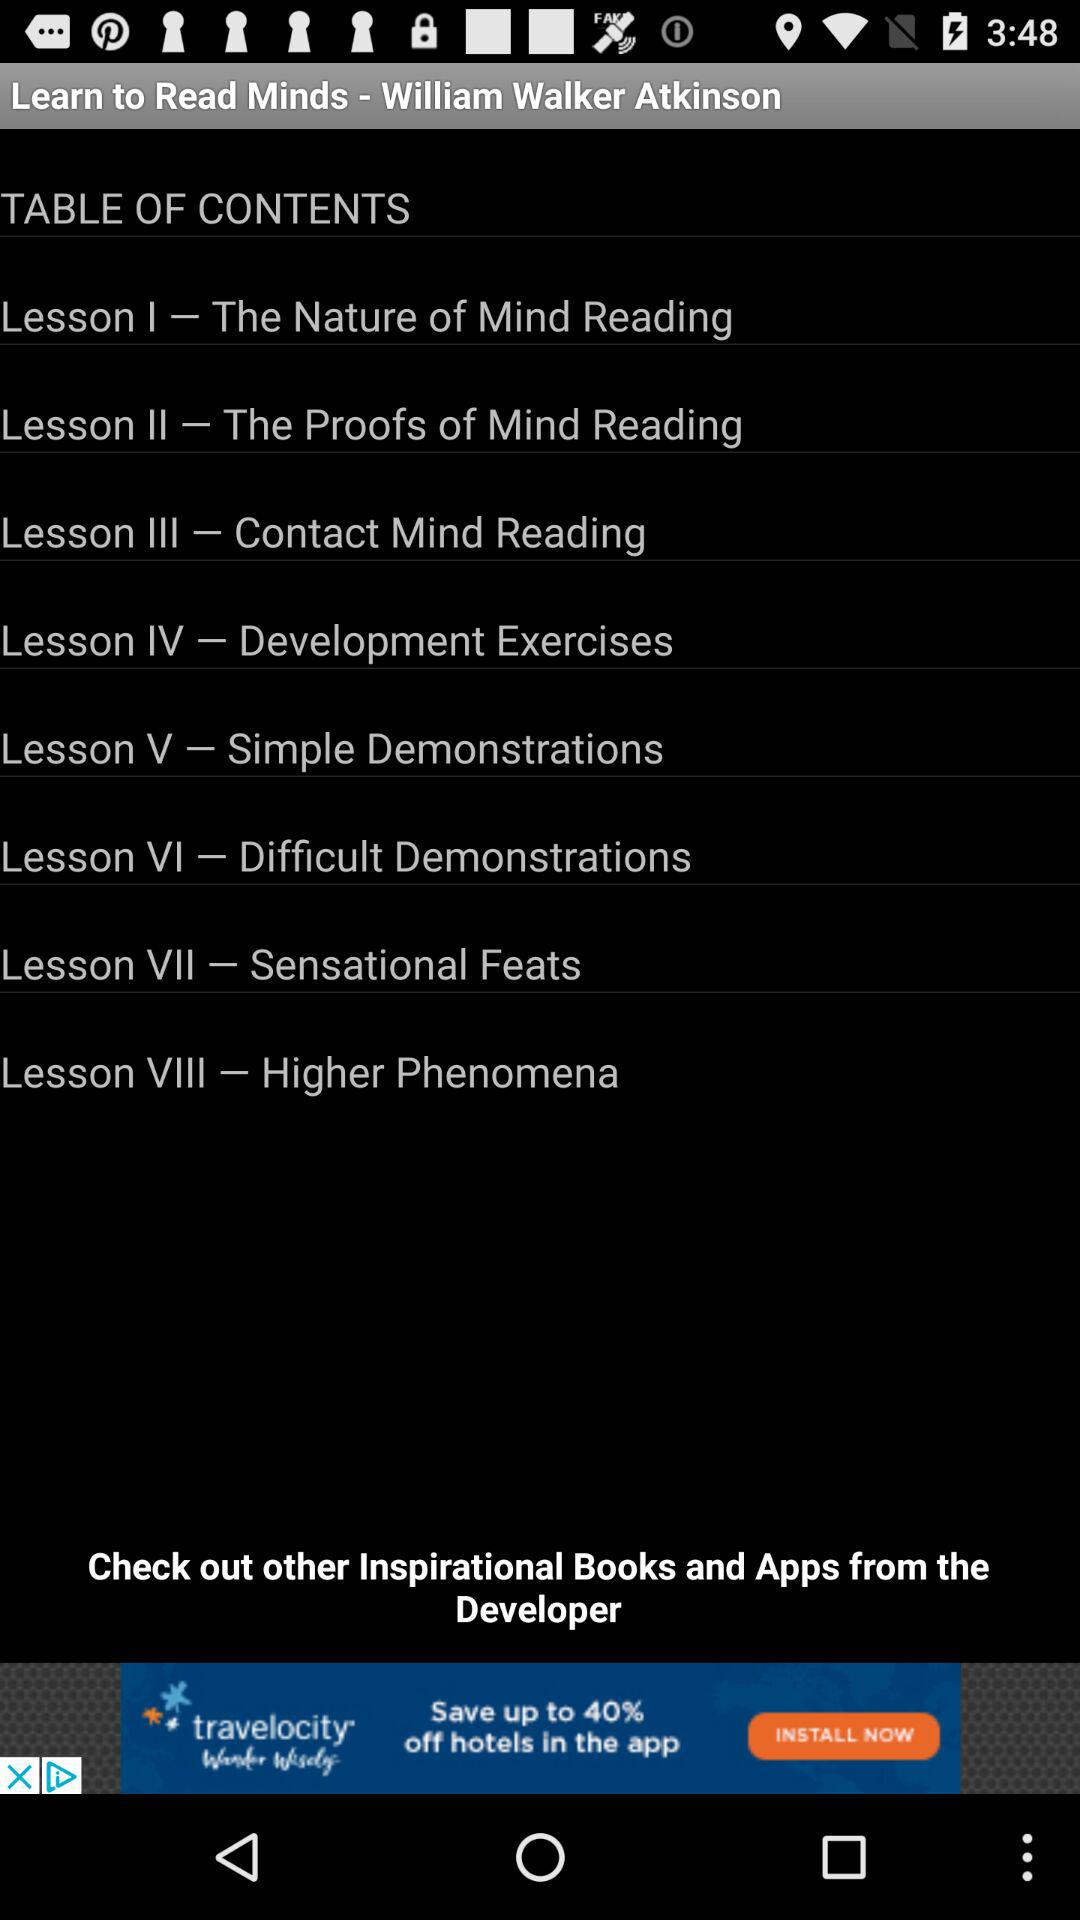What is the title of "Lesson II"? The title is "The Proofs of Mind Reading". 